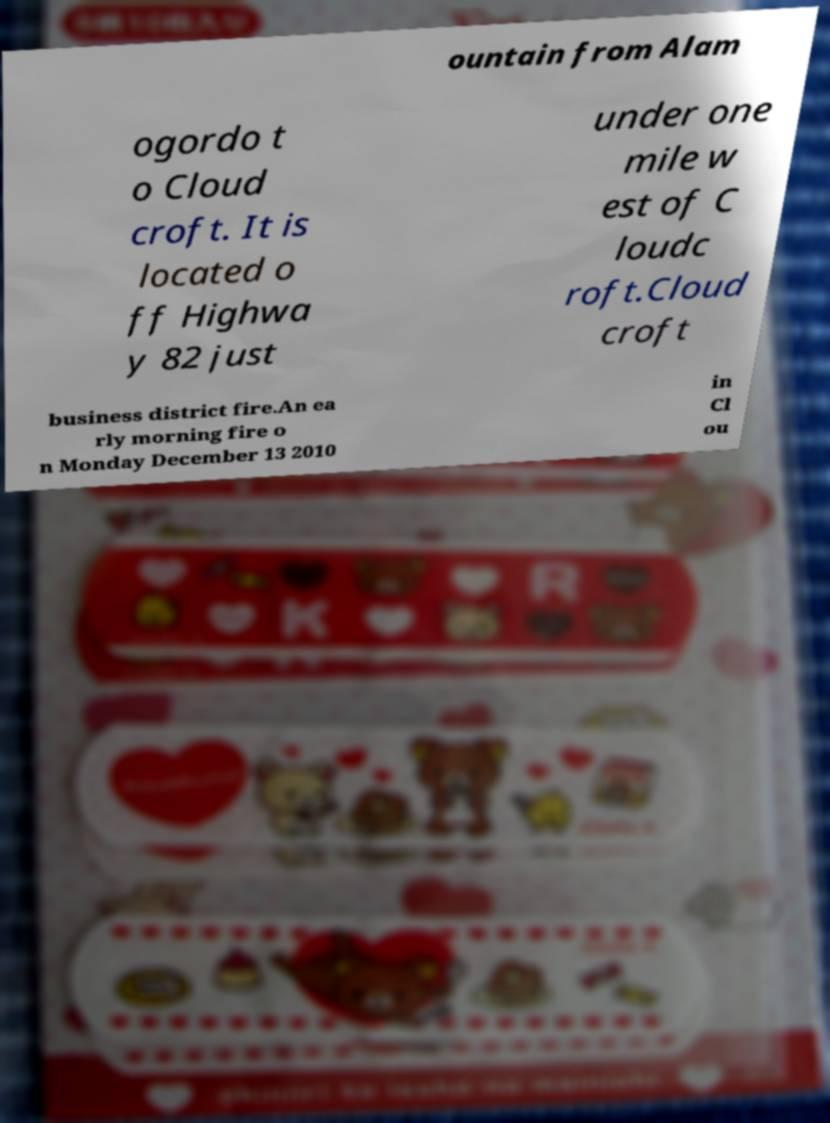For documentation purposes, I need the text within this image transcribed. Could you provide that? ountain from Alam ogordo t o Cloud croft. It is located o ff Highwa y 82 just under one mile w est of C loudc roft.Cloud croft business district fire.An ea rly morning fire o n Monday December 13 2010 in Cl ou 